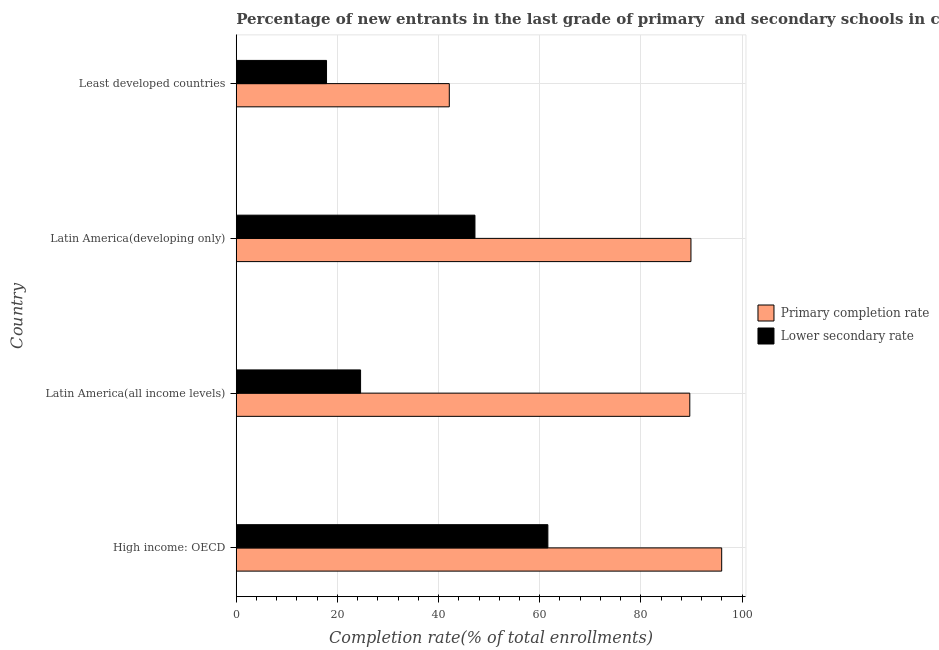How many different coloured bars are there?
Your answer should be very brief. 2. Are the number of bars per tick equal to the number of legend labels?
Provide a short and direct response. Yes. How many bars are there on the 1st tick from the bottom?
Your answer should be very brief. 2. What is the label of the 2nd group of bars from the top?
Ensure brevity in your answer.  Latin America(developing only). In how many cases, is the number of bars for a given country not equal to the number of legend labels?
Provide a succinct answer. 0. What is the completion rate in secondary schools in Latin America(developing only)?
Ensure brevity in your answer.  47.19. Across all countries, what is the maximum completion rate in secondary schools?
Keep it short and to the point. 61.61. Across all countries, what is the minimum completion rate in primary schools?
Provide a short and direct response. 42.12. In which country was the completion rate in primary schools maximum?
Provide a succinct answer. High income: OECD. In which country was the completion rate in secondary schools minimum?
Your answer should be very brief. Least developed countries. What is the total completion rate in primary schools in the graph?
Give a very brief answer. 317.68. What is the difference between the completion rate in secondary schools in High income: OECD and that in Latin America(all income levels)?
Your answer should be very brief. 37.03. What is the difference between the completion rate in primary schools in Least developed countries and the completion rate in secondary schools in High income: OECD?
Keep it short and to the point. -19.49. What is the average completion rate in secondary schools per country?
Your answer should be very brief. 37.81. What is the difference between the completion rate in primary schools and completion rate in secondary schools in Latin America(all income levels)?
Your answer should be very brief. 65.09. In how many countries, is the completion rate in primary schools greater than 12 %?
Give a very brief answer. 4. What is the ratio of the completion rate in secondary schools in High income: OECD to that in Latin America(all income levels)?
Provide a succinct answer. 2.51. What is the difference between the highest and the second highest completion rate in primary schools?
Offer a terse response. 6.08. What is the difference between the highest and the lowest completion rate in secondary schools?
Offer a very short reply. 43.76. What does the 1st bar from the top in Least developed countries represents?
Give a very brief answer. Lower secondary rate. What does the 2nd bar from the bottom in Least developed countries represents?
Give a very brief answer. Lower secondary rate. How many countries are there in the graph?
Your answer should be very brief. 4. Does the graph contain grids?
Your answer should be very brief. Yes. How are the legend labels stacked?
Offer a terse response. Vertical. What is the title of the graph?
Make the answer very short. Percentage of new entrants in the last grade of primary  and secondary schools in countries. What is the label or title of the X-axis?
Keep it short and to the point. Completion rate(% of total enrollments). What is the label or title of the Y-axis?
Your response must be concise. Country. What is the Completion rate(% of total enrollments) of Primary completion rate in High income: OECD?
Provide a succinct answer. 95.98. What is the Completion rate(% of total enrollments) in Lower secondary rate in High income: OECD?
Keep it short and to the point. 61.61. What is the Completion rate(% of total enrollments) in Primary completion rate in Latin America(all income levels)?
Offer a very short reply. 89.67. What is the Completion rate(% of total enrollments) of Lower secondary rate in Latin America(all income levels)?
Provide a succinct answer. 24.58. What is the Completion rate(% of total enrollments) in Primary completion rate in Latin America(developing only)?
Provide a short and direct response. 89.9. What is the Completion rate(% of total enrollments) of Lower secondary rate in Latin America(developing only)?
Give a very brief answer. 47.19. What is the Completion rate(% of total enrollments) in Primary completion rate in Least developed countries?
Your answer should be compact. 42.12. What is the Completion rate(% of total enrollments) in Lower secondary rate in Least developed countries?
Your response must be concise. 17.85. Across all countries, what is the maximum Completion rate(% of total enrollments) in Primary completion rate?
Ensure brevity in your answer.  95.98. Across all countries, what is the maximum Completion rate(% of total enrollments) of Lower secondary rate?
Offer a terse response. 61.61. Across all countries, what is the minimum Completion rate(% of total enrollments) in Primary completion rate?
Keep it short and to the point. 42.12. Across all countries, what is the minimum Completion rate(% of total enrollments) of Lower secondary rate?
Ensure brevity in your answer.  17.85. What is the total Completion rate(% of total enrollments) of Primary completion rate in the graph?
Offer a terse response. 317.68. What is the total Completion rate(% of total enrollments) of Lower secondary rate in the graph?
Provide a succinct answer. 151.24. What is the difference between the Completion rate(% of total enrollments) of Primary completion rate in High income: OECD and that in Latin America(all income levels)?
Your answer should be very brief. 6.31. What is the difference between the Completion rate(% of total enrollments) in Lower secondary rate in High income: OECD and that in Latin America(all income levels)?
Keep it short and to the point. 37.03. What is the difference between the Completion rate(% of total enrollments) in Primary completion rate in High income: OECD and that in Latin America(developing only)?
Your response must be concise. 6.08. What is the difference between the Completion rate(% of total enrollments) of Lower secondary rate in High income: OECD and that in Latin America(developing only)?
Your answer should be very brief. 14.42. What is the difference between the Completion rate(% of total enrollments) in Primary completion rate in High income: OECD and that in Least developed countries?
Your answer should be very brief. 53.86. What is the difference between the Completion rate(% of total enrollments) in Lower secondary rate in High income: OECD and that in Least developed countries?
Keep it short and to the point. 43.76. What is the difference between the Completion rate(% of total enrollments) of Primary completion rate in Latin America(all income levels) and that in Latin America(developing only)?
Provide a succinct answer. -0.23. What is the difference between the Completion rate(% of total enrollments) of Lower secondary rate in Latin America(all income levels) and that in Latin America(developing only)?
Your answer should be very brief. -22.61. What is the difference between the Completion rate(% of total enrollments) in Primary completion rate in Latin America(all income levels) and that in Least developed countries?
Ensure brevity in your answer.  47.55. What is the difference between the Completion rate(% of total enrollments) in Lower secondary rate in Latin America(all income levels) and that in Least developed countries?
Provide a succinct answer. 6.73. What is the difference between the Completion rate(% of total enrollments) of Primary completion rate in Latin America(developing only) and that in Least developed countries?
Give a very brief answer. 47.78. What is the difference between the Completion rate(% of total enrollments) of Lower secondary rate in Latin America(developing only) and that in Least developed countries?
Ensure brevity in your answer.  29.34. What is the difference between the Completion rate(% of total enrollments) in Primary completion rate in High income: OECD and the Completion rate(% of total enrollments) in Lower secondary rate in Latin America(all income levels)?
Keep it short and to the point. 71.4. What is the difference between the Completion rate(% of total enrollments) of Primary completion rate in High income: OECD and the Completion rate(% of total enrollments) of Lower secondary rate in Latin America(developing only)?
Offer a terse response. 48.79. What is the difference between the Completion rate(% of total enrollments) of Primary completion rate in High income: OECD and the Completion rate(% of total enrollments) of Lower secondary rate in Least developed countries?
Offer a terse response. 78.13. What is the difference between the Completion rate(% of total enrollments) in Primary completion rate in Latin America(all income levels) and the Completion rate(% of total enrollments) in Lower secondary rate in Latin America(developing only)?
Your answer should be very brief. 42.48. What is the difference between the Completion rate(% of total enrollments) in Primary completion rate in Latin America(all income levels) and the Completion rate(% of total enrollments) in Lower secondary rate in Least developed countries?
Make the answer very short. 71.82. What is the difference between the Completion rate(% of total enrollments) in Primary completion rate in Latin America(developing only) and the Completion rate(% of total enrollments) in Lower secondary rate in Least developed countries?
Give a very brief answer. 72.05. What is the average Completion rate(% of total enrollments) of Primary completion rate per country?
Your answer should be compact. 79.42. What is the average Completion rate(% of total enrollments) of Lower secondary rate per country?
Your answer should be very brief. 37.81. What is the difference between the Completion rate(% of total enrollments) of Primary completion rate and Completion rate(% of total enrollments) of Lower secondary rate in High income: OECD?
Make the answer very short. 34.37. What is the difference between the Completion rate(% of total enrollments) of Primary completion rate and Completion rate(% of total enrollments) of Lower secondary rate in Latin America(all income levels)?
Offer a terse response. 65.09. What is the difference between the Completion rate(% of total enrollments) in Primary completion rate and Completion rate(% of total enrollments) in Lower secondary rate in Latin America(developing only)?
Give a very brief answer. 42.71. What is the difference between the Completion rate(% of total enrollments) of Primary completion rate and Completion rate(% of total enrollments) of Lower secondary rate in Least developed countries?
Offer a very short reply. 24.27. What is the ratio of the Completion rate(% of total enrollments) of Primary completion rate in High income: OECD to that in Latin America(all income levels)?
Your answer should be compact. 1.07. What is the ratio of the Completion rate(% of total enrollments) of Lower secondary rate in High income: OECD to that in Latin America(all income levels)?
Ensure brevity in your answer.  2.51. What is the ratio of the Completion rate(% of total enrollments) in Primary completion rate in High income: OECD to that in Latin America(developing only)?
Ensure brevity in your answer.  1.07. What is the ratio of the Completion rate(% of total enrollments) of Lower secondary rate in High income: OECD to that in Latin America(developing only)?
Offer a terse response. 1.31. What is the ratio of the Completion rate(% of total enrollments) of Primary completion rate in High income: OECD to that in Least developed countries?
Ensure brevity in your answer.  2.28. What is the ratio of the Completion rate(% of total enrollments) in Lower secondary rate in High income: OECD to that in Least developed countries?
Your answer should be very brief. 3.45. What is the ratio of the Completion rate(% of total enrollments) in Primary completion rate in Latin America(all income levels) to that in Latin America(developing only)?
Ensure brevity in your answer.  1. What is the ratio of the Completion rate(% of total enrollments) of Lower secondary rate in Latin America(all income levels) to that in Latin America(developing only)?
Ensure brevity in your answer.  0.52. What is the ratio of the Completion rate(% of total enrollments) of Primary completion rate in Latin America(all income levels) to that in Least developed countries?
Offer a terse response. 2.13. What is the ratio of the Completion rate(% of total enrollments) of Lower secondary rate in Latin America(all income levels) to that in Least developed countries?
Provide a short and direct response. 1.38. What is the ratio of the Completion rate(% of total enrollments) of Primary completion rate in Latin America(developing only) to that in Least developed countries?
Your answer should be very brief. 2.13. What is the ratio of the Completion rate(% of total enrollments) of Lower secondary rate in Latin America(developing only) to that in Least developed countries?
Ensure brevity in your answer.  2.64. What is the difference between the highest and the second highest Completion rate(% of total enrollments) of Primary completion rate?
Your answer should be very brief. 6.08. What is the difference between the highest and the second highest Completion rate(% of total enrollments) in Lower secondary rate?
Give a very brief answer. 14.42. What is the difference between the highest and the lowest Completion rate(% of total enrollments) in Primary completion rate?
Make the answer very short. 53.86. What is the difference between the highest and the lowest Completion rate(% of total enrollments) of Lower secondary rate?
Make the answer very short. 43.76. 